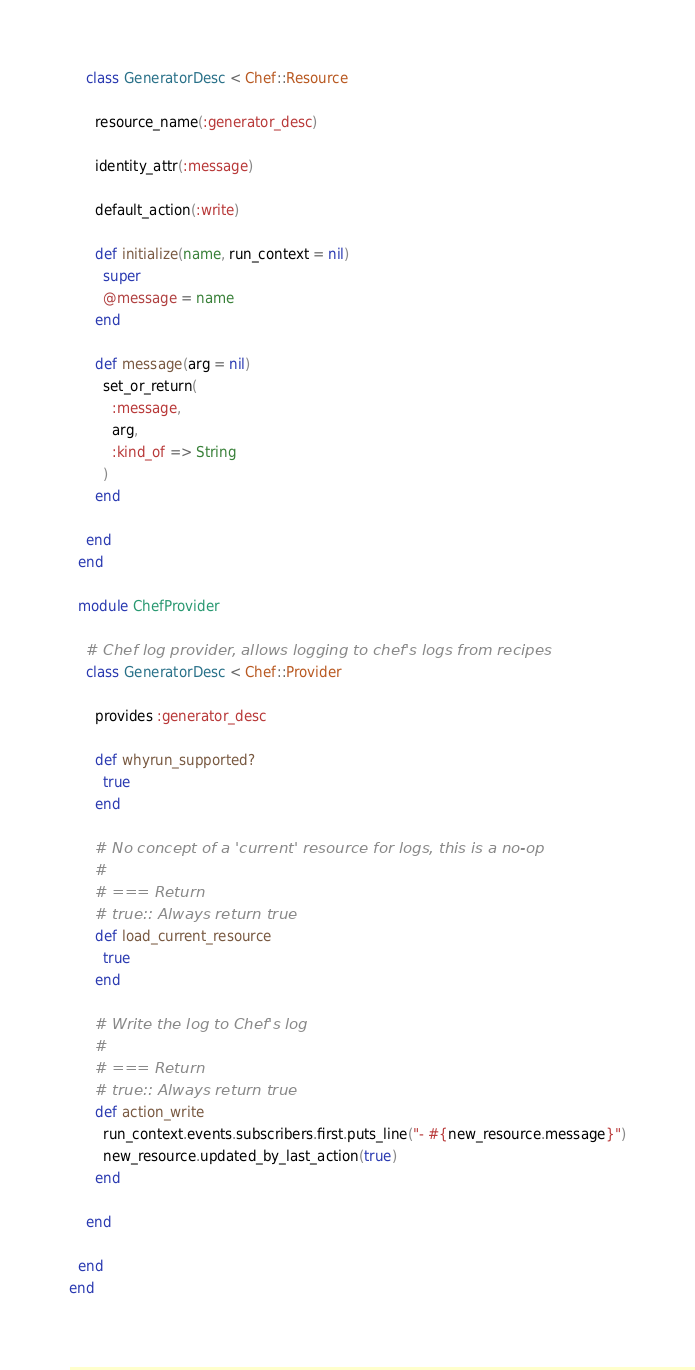<code> <loc_0><loc_0><loc_500><loc_500><_Ruby_>    class GeneratorDesc < Chef::Resource

      resource_name(:generator_desc)

      identity_attr(:message)

      default_action(:write)

      def initialize(name, run_context = nil)
        super
        @message = name
      end

      def message(arg = nil)
        set_or_return(
          :message,
          arg,
          :kind_of => String
        )
      end

    end
  end

  module ChefProvider

    # Chef log provider, allows logging to chef's logs from recipes
    class GeneratorDesc < Chef::Provider

      provides :generator_desc

      def whyrun_supported?
        true
      end

      # No concept of a 'current' resource for logs, this is a no-op
      #
      # === Return
      # true:: Always return true
      def load_current_resource
        true
      end

      # Write the log to Chef's log
      #
      # === Return
      # true:: Always return true
      def action_write
        run_context.events.subscribers.first.puts_line("- #{new_resource.message}")
        new_resource.updated_by_last_action(true)
      end

    end

  end
end
</code> 